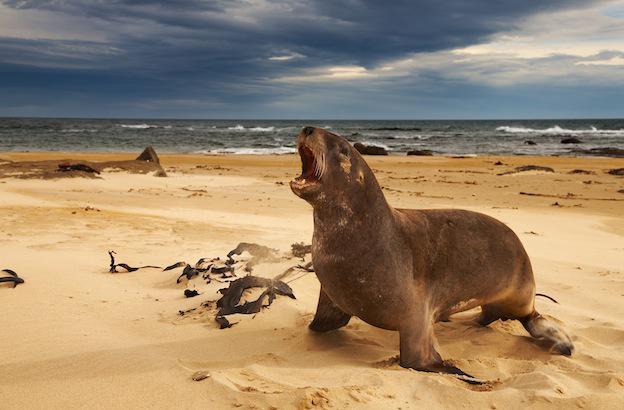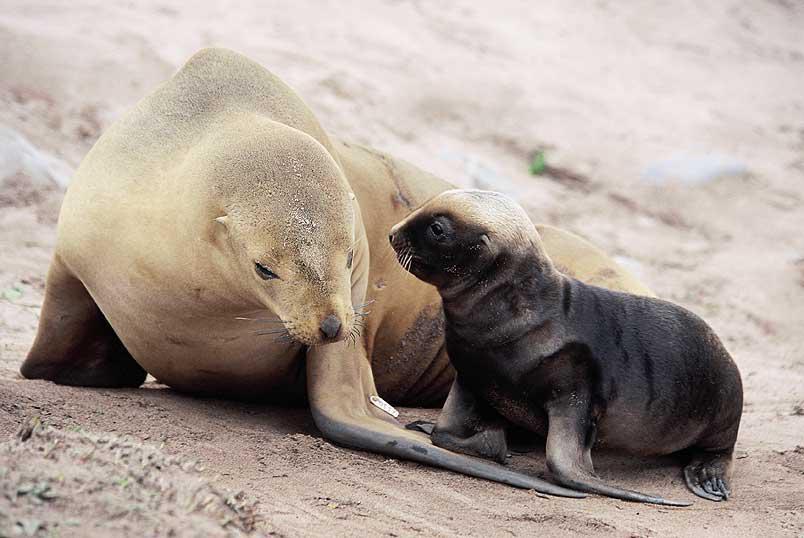The first image is the image on the left, the second image is the image on the right. Given the left and right images, does the statement "Right and left image contain the same number of seals." hold true? Answer yes or no. No. The first image is the image on the left, the second image is the image on the right. For the images displayed, is the sentence "An image shows at least one small dark seal pup next to a larger paler adult seal." factually correct? Answer yes or no. Yes. The first image is the image on the left, the second image is the image on the right. Analyze the images presented: Is the assertion "There are exactly three animals in the image on the right." valid? Answer yes or no. No. The first image is the image on the left, the second image is the image on the right. Analyze the images presented: Is the assertion "The photo on the right contains three or more animals." valid? Answer yes or no. No. 